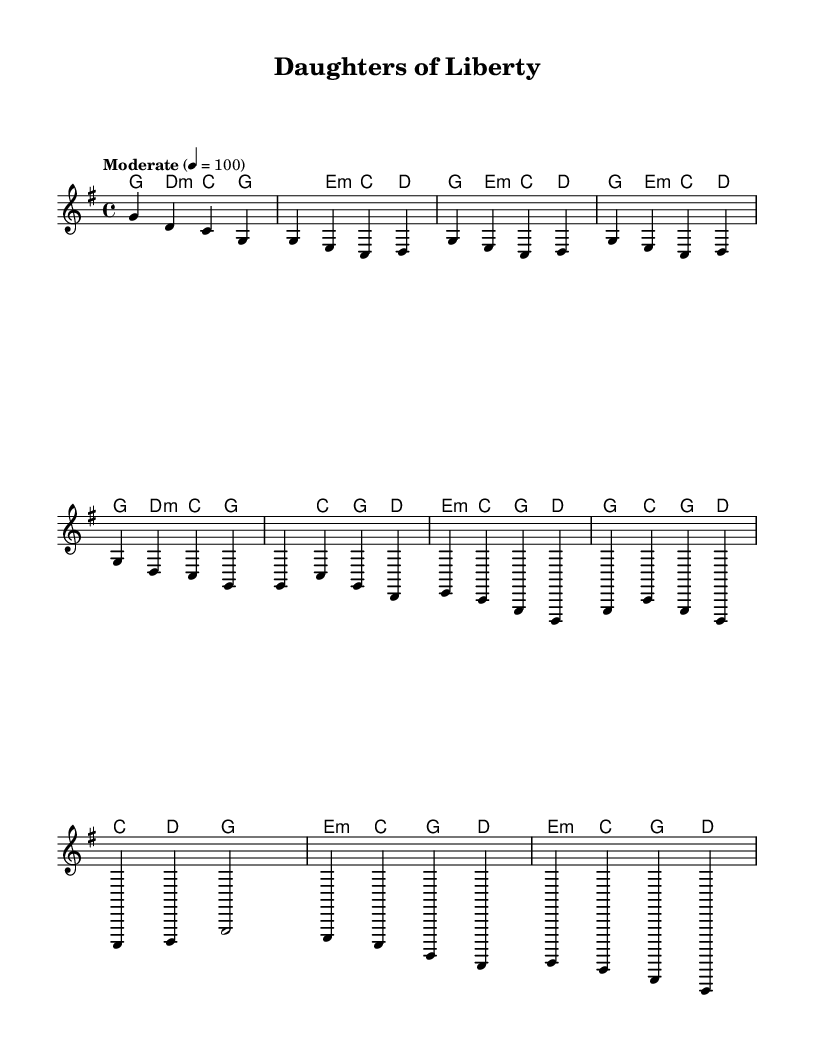What is the key signature of this music? The key signature is G major, which has one sharp (F#).
Answer: G major What is the time signature of this music? The time signature is 4/4, meaning there are four beats in each measure and the quarter note gets one beat.
Answer: 4/4 What is the tempo indication provided? The tempo is indicated as "Moderate" with a marking of 4 beats per minute equals 100, suggesting a moderate pace.
Answer: Moderate 4 = 100 How many measures are there in the chorus section? By counting the measures specifically designated as the chorus, we see that there are 4 measures in that section.
Answer: 4 Which chord is played in the first measure? The first measure corresponds to the G major chord, as indicated in the harmonic progression.
Answer: G What is the pattern of the melody in the bridge section? Analyzing the bridge, the melody alternates between E, C, G, and D, reflecting a typical structure of verse-related sections.
Answer: E, C, G, D What is the last chord in the score? The last chord as indicated at the end of the musical score is the D minor chord, highlighting its resolution.
Answer: D minor 